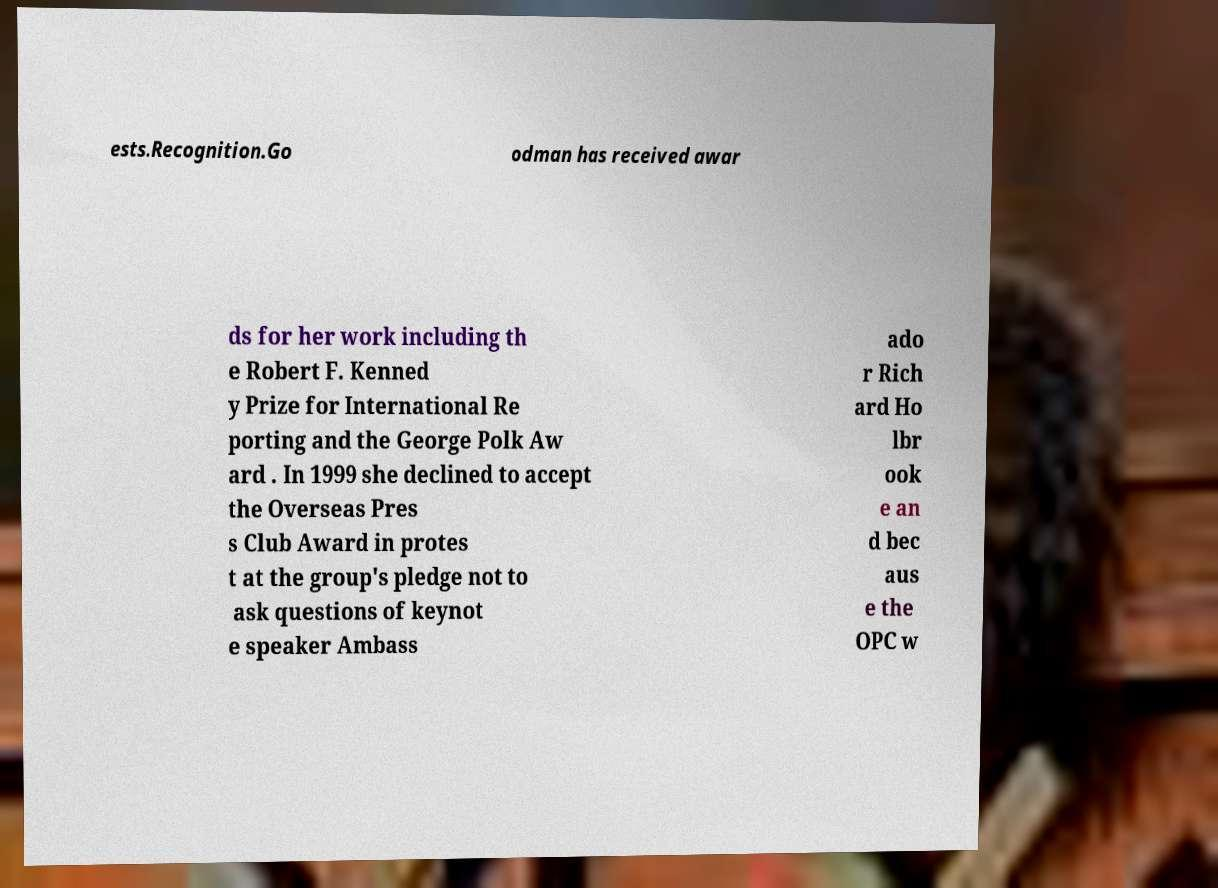Please read and relay the text visible in this image. What does it say? ests.Recognition.Go odman has received awar ds for her work including th e Robert F. Kenned y Prize for International Re porting and the George Polk Aw ard . In 1999 she declined to accept the Overseas Pres s Club Award in protes t at the group's pledge not to ask questions of keynot e speaker Ambass ado r Rich ard Ho lbr ook e an d bec aus e the OPC w 